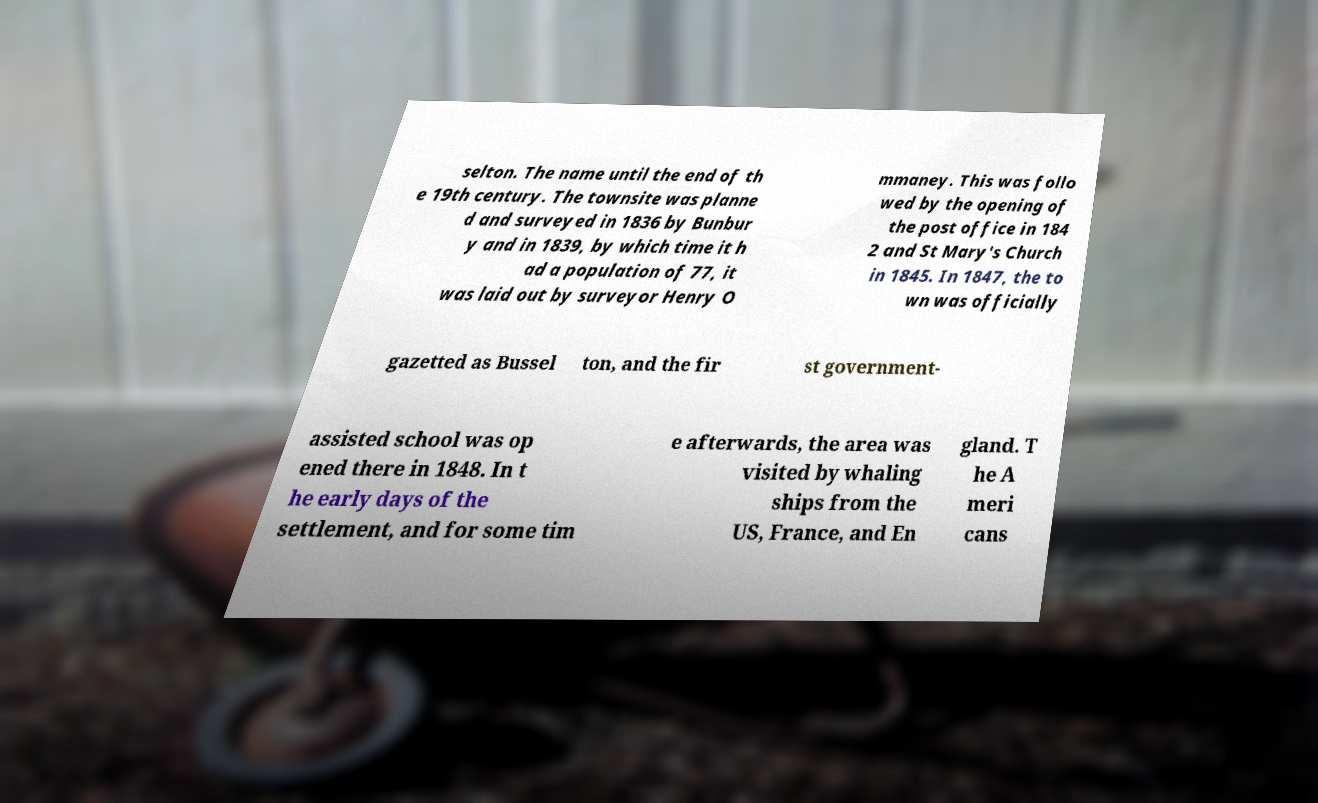Could you extract and type out the text from this image? selton. The name until the end of th e 19th century. The townsite was planne d and surveyed in 1836 by Bunbur y and in 1839, by which time it h ad a population of 77, it was laid out by surveyor Henry O mmaney. This was follo wed by the opening of the post office in 184 2 and St Mary's Church in 1845. In 1847, the to wn was officially gazetted as Bussel ton, and the fir st government- assisted school was op ened there in 1848. In t he early days of the settlement, and for some tim e afterwards, the area was visited by whaling ships from the US, France, and En gland. T he A meri cans 